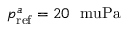<formula> <loc_0><loc_0><loc_500><loc_500>p _ { r e f } ^ { a } = 2 0 \ m u P a</formula> 